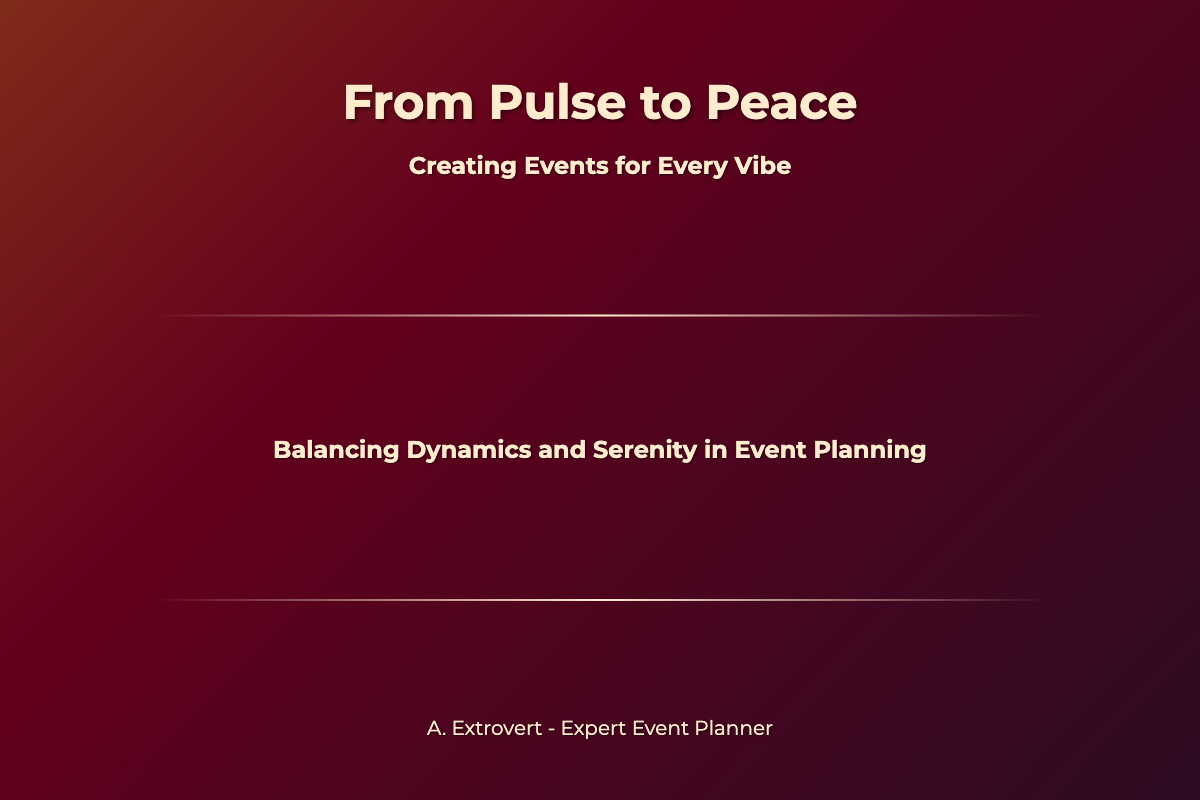What is the title of the book? The title appears prominently at the top of the cover and is styled in large font.
Answer: From Pulse to Peace What is the subtitle of the book? The subtitle is located below the title and clarifies the book's focus.
Answer: Creating Events for Every Vibe Who is the author of the book? The author's name is presented at the bottom section of the cover.
Answer: A. Extrovert - Expert Event Planner What visual elements contrast on the cover? The cover features two distinct scenes representing different vibes.
Answer: Cityscape and lakeside How many sections are in the content of the book cover? The content layout divides the title, subtitle, and author's name into distinct sections.
Answer: Three sections What color scheme is used for the text? The choice of color can enhance the visibility of the text against the background.
Answer: Light color on a dark background What is the overall theme of the book? The title and subtitle suggest a balance of two opposing atmospheres in event planning.
Answer: Balancing dynamics and serenity What design technique is used for the background? The background of the cover employs visual elements that blend two contrasting environments.
Answer: Gradient background What type of book is this? The format and title suggest a focus on event planning.
Answer: Non-fiction or guide 